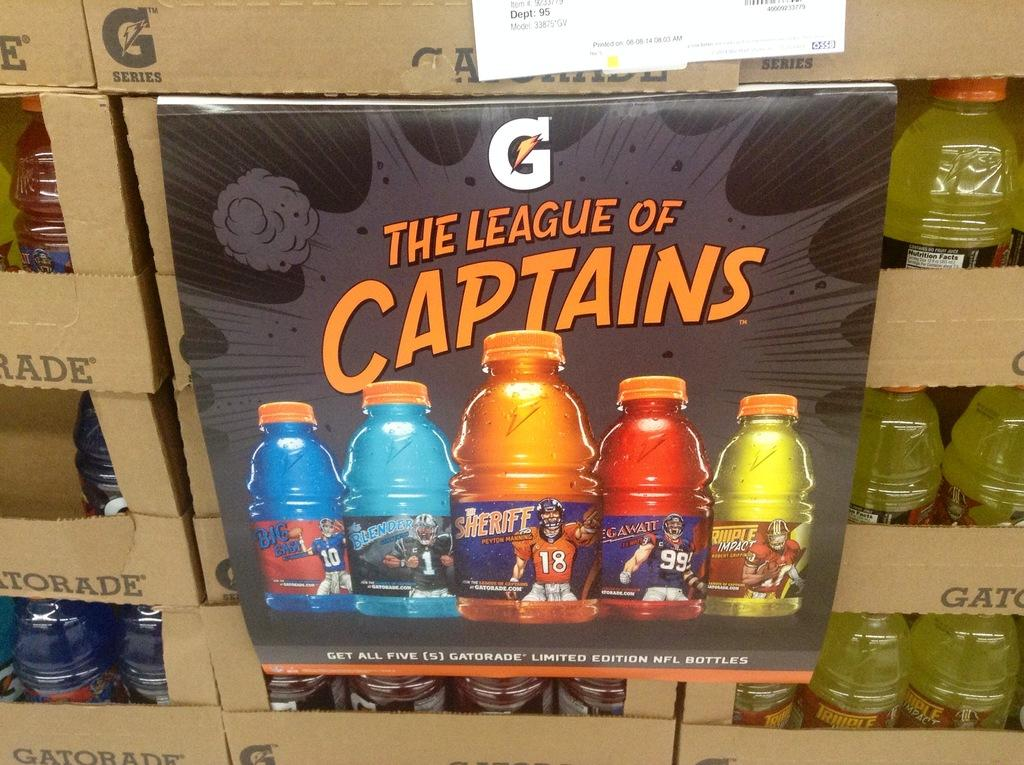<image>
Offer a succinct explanation of the picture presented. Gatorade bottles are arranged in boxes behind a sign that says The League of Captains. 